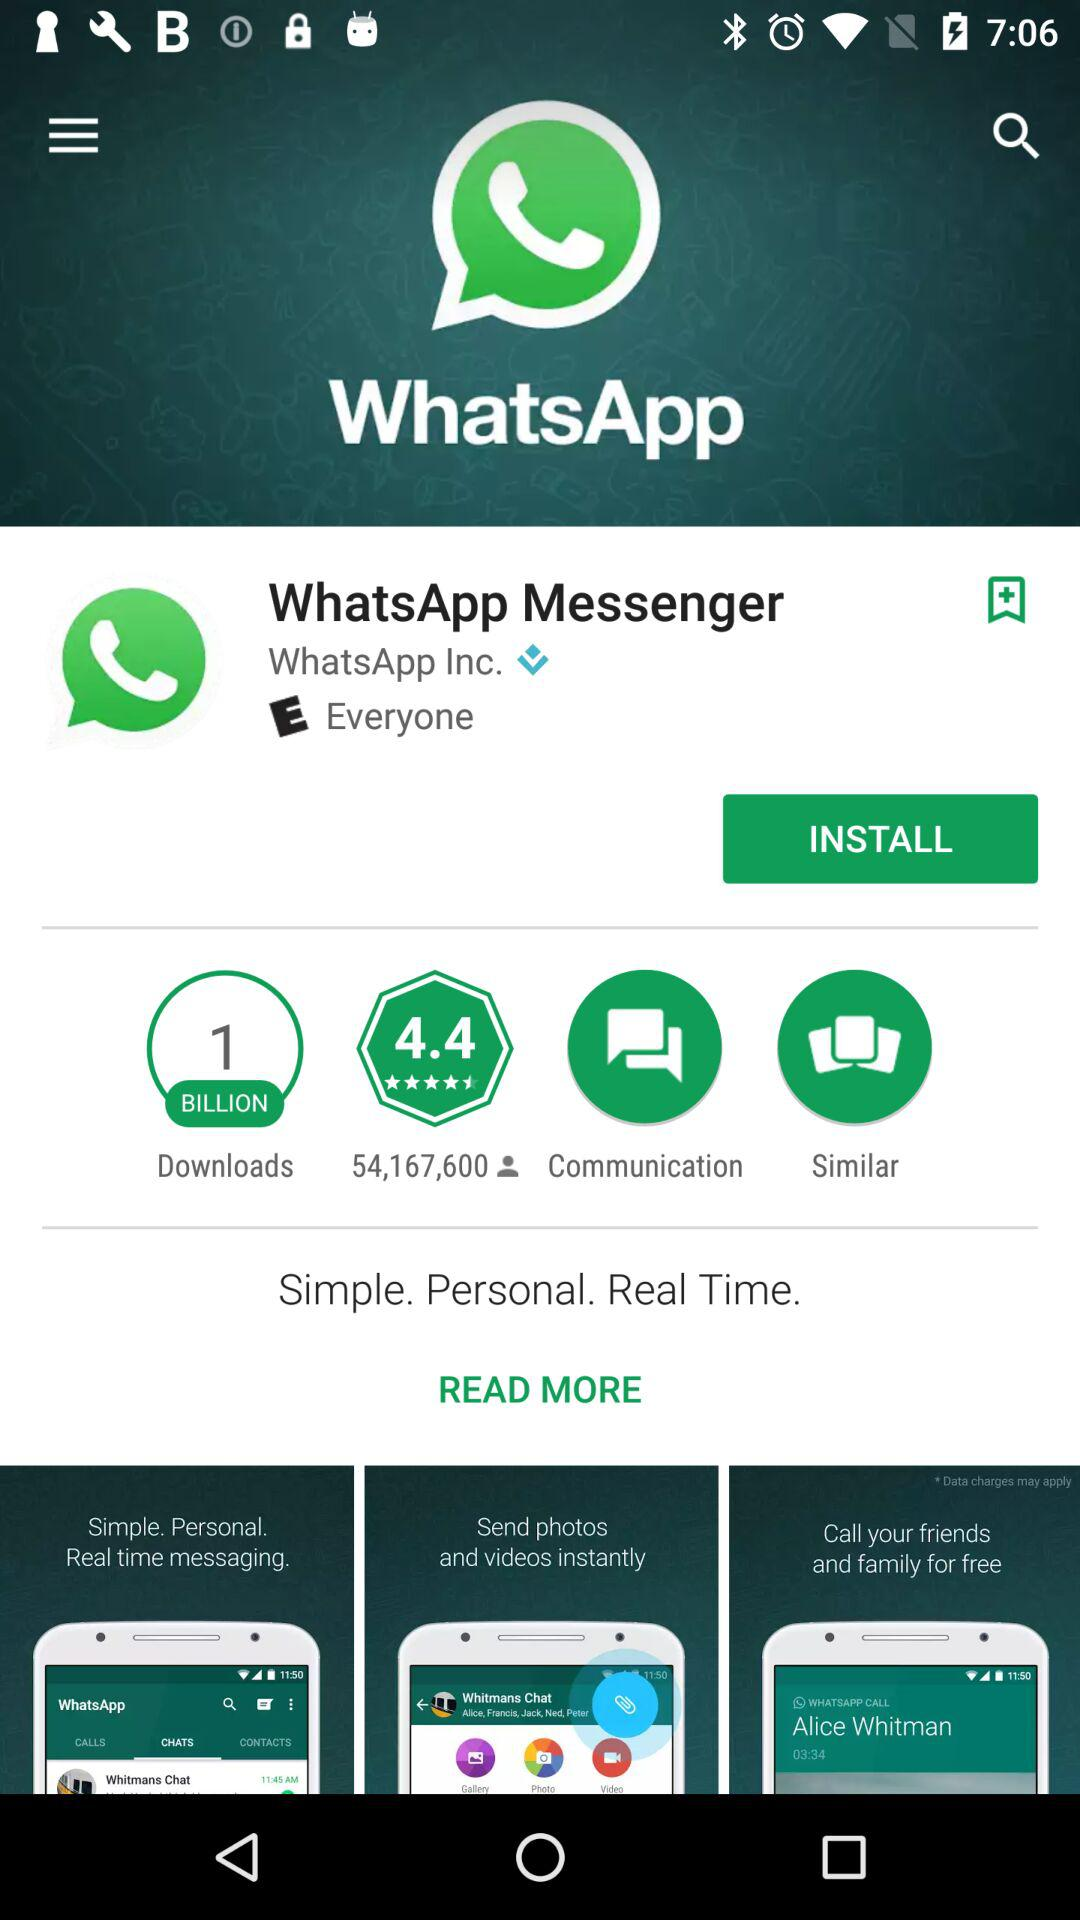What is the rating of WhatsApp Messenger? The rating is 4.4. 